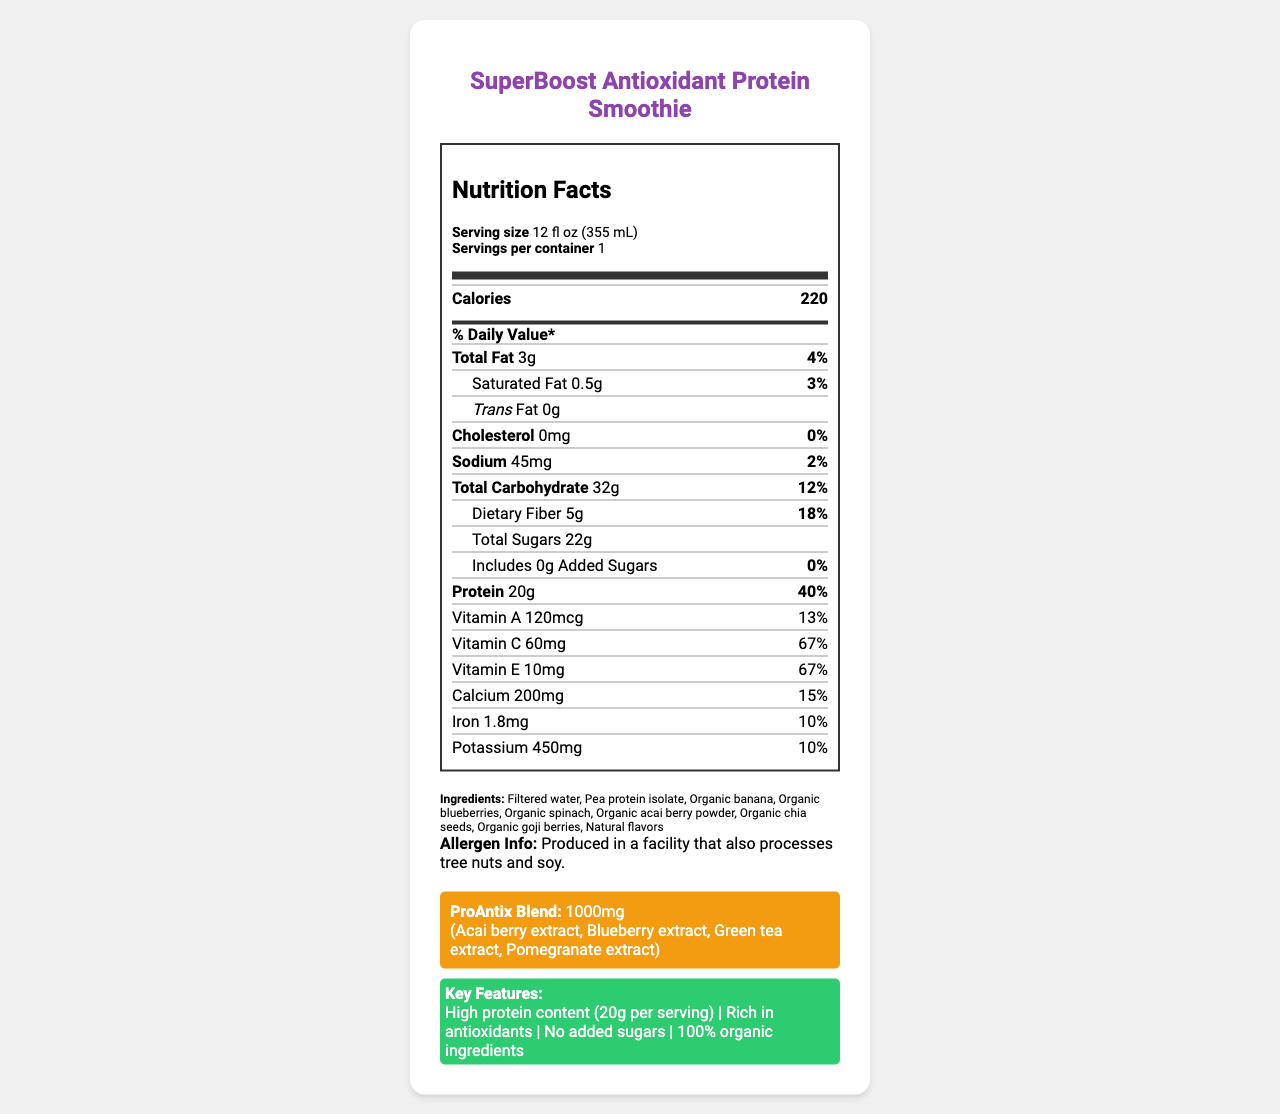what is the serving size? The serving size is explicitly stated at the top of the Nutrition Facts label as "Serving size 12 fl oz (355 mL)".
Answer: 12 fl oz (355 mL) how many calories are in one serving? The calorie count is displayed prominently under the nutrient header as "Calories 220".
Answer: 220 what percentage of Daily Value (%DV) does the protein provide? The % Daily Value for protein is listed as "40%" next to the protein amount on the label.
Answer: 40% list the ingredients in the SuperBoost Antioxidant Protein Smoothie. The ingredients are listed towards the bottom of the document in the "Ingredients" section.
Answer: Filtered water, Pea protein isolate, Organic banana, Organic blueberries, Organic spinach, Organic acai berry powder, Organic chia seeds, Organic goji berries, Natural flavors what is the daily value percentage for Vitamin C? The % Daily Value for Vitamin C is shown in the nutrient list as "67%".
Answer: 67% what is the total amount of dietary fiber? A. 22g B. 5g C. 10g D. 3g The total dietary fiber is listed in the nutrient section as "Dietary Fiber 5g".
Answer: B how much calcium does one serving contain? A. 100mg B. 200mg C. 150mg D. 50mg The amount of calcium per serving is given as "Calcium 200mg".
Answer: B is there any trans fat in the smoothie? The amount of trans fat is listed as "0g," indicating there are no trans fats in the smoothie.
Answer: No is the smoothie made with 100% organic ingredients? The editor's notes highlight that the product contains "100% organic ingredients," indicating all components are organic.
Answer: Yes summarize the main features of this SuperBoost Antioxidant Protein Smoothie. The summary captures the key nutritional elements, including high protein, antioxidant content, organic ingredients, and specific vitamins and minerals present in the smoothie.
Answer: The SuperBoost Antioxidant Protein Smoothie is a high-protein drink (20g per serving) rich in antioxidants, with a serving size of 12 fl oz. It contains 220 calories and is made with 100% organic ingredients including pea protein, various fruits, and natural flavors. It is free from added sugars and trans fats and provides significant daily values of Vitamins A, C, and E. The smoothie also includes a unique ProAntix Blend of antioxidant extracts. who is the manufacturer of the smoothie? The document does not provide any information about the manufacturer of the smoothie.
Answer: Cannot be determined 